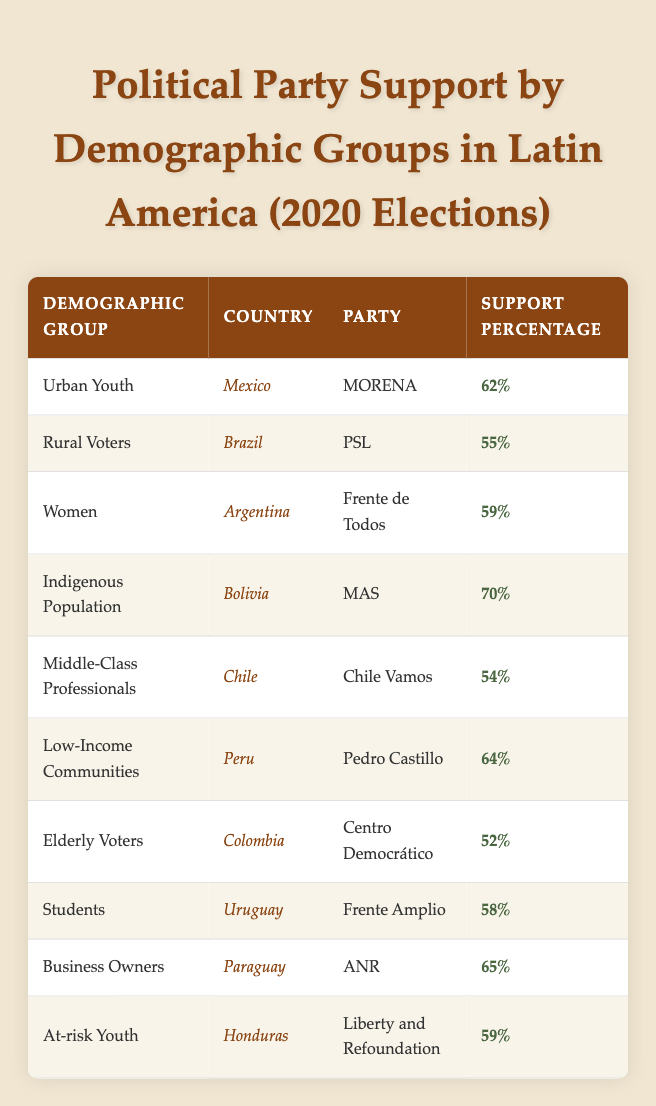What percentage of support did the Indigenous Population have in Bolivia? The table shows that the Indigenous Population in Bolivia supported the MAS party with a percentage of 70%.
Answer: 70% Which political party received the most support from Women in Argentina? According to the table, the Women demographic in Argentina supported the Frente de Todos party with a percentage of 59%.
Answer: Frente de Todos What is the average support percentage for the Urban Youth group across all countries? The Urban Youth group has a support percentage of 62% in Mexico. There is only one data point for this demographic, thus the average is simply 62%.
Answer: 62% Did Business Owners in Paraguay support the ANR party more than 60%? The table indicates that Business Owners in Paraguay supported the ANR party with a percentage of 65%. Since 65% is greater than 60%, the answer is yes.
Answer: Yes How does the support for Low-Income Communities compare with that of Elderly Voters in their respective countries? Low-Income Communities in Peru supported Pedro Castillo at 64%, while Elderly Voters in Colombia supported Centro Democrático at 52%. When comparing the two, Low-Income Communities have a higher support percentage by 12%.
Answer: 12% higher Which country had the highest reported support for any party, and what was that percentage? By inspecting the table, the highest support comes from the Indigenous Population in Bolivia for the MAS party, reporting 70%, which is greater than any other percentage in the table.
Answer: Bolivia, 70% Is the support percentage for Middle-Class Professionals in Chile higher than the support for Women in Argentina? The support for Middle-Class Professionals in Chile is 54% while the support for Women in Argentina is 59%. Therefore, 54% is less than 59%, making the answer no.
Answer: No What is the total support percentage of the three groups with the highest support percentages listed in the table? The three highest support percentages from the table are 70% (Indigenous Population), 65% (Business Owners), and 64% (Low-Income Communities). Summing these gives us 70 + 65 + 64 = 199%. Consequently, the total support percentage for the top three groups is 199%.
Answer: 199% 